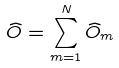<formula> <loc_0><loc_0><loc_500><loc_500>\widehat { O } = \sum _ { m = 1 } ^ { N } \widehat { O } _ { m }</formula> 